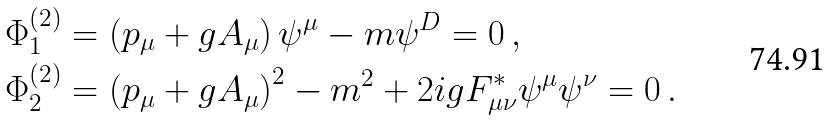Convert formula to latex. <formula><loc_0><loc_0><loc_500><loc_500>& \Phi _ { 1 } ^ { ( 2 ) } = \left ( p _ { \mu } + g A _ { \mu } \right ) \psi ^ { \mu } - m \psi ^ { D } = 0 \, , \\ & \Phi _ { 2 } ^ { ( 2 ) } = \left ( p _ { \mu } + g A _ { \mu } \right ) ^ { 2 } - m ^ { 2 } + 2 i g F _ { \mu \nu } ^ { \ast } \psi ^ { \mu } \psi ^ { \nu } = 0 \, .</formula> 